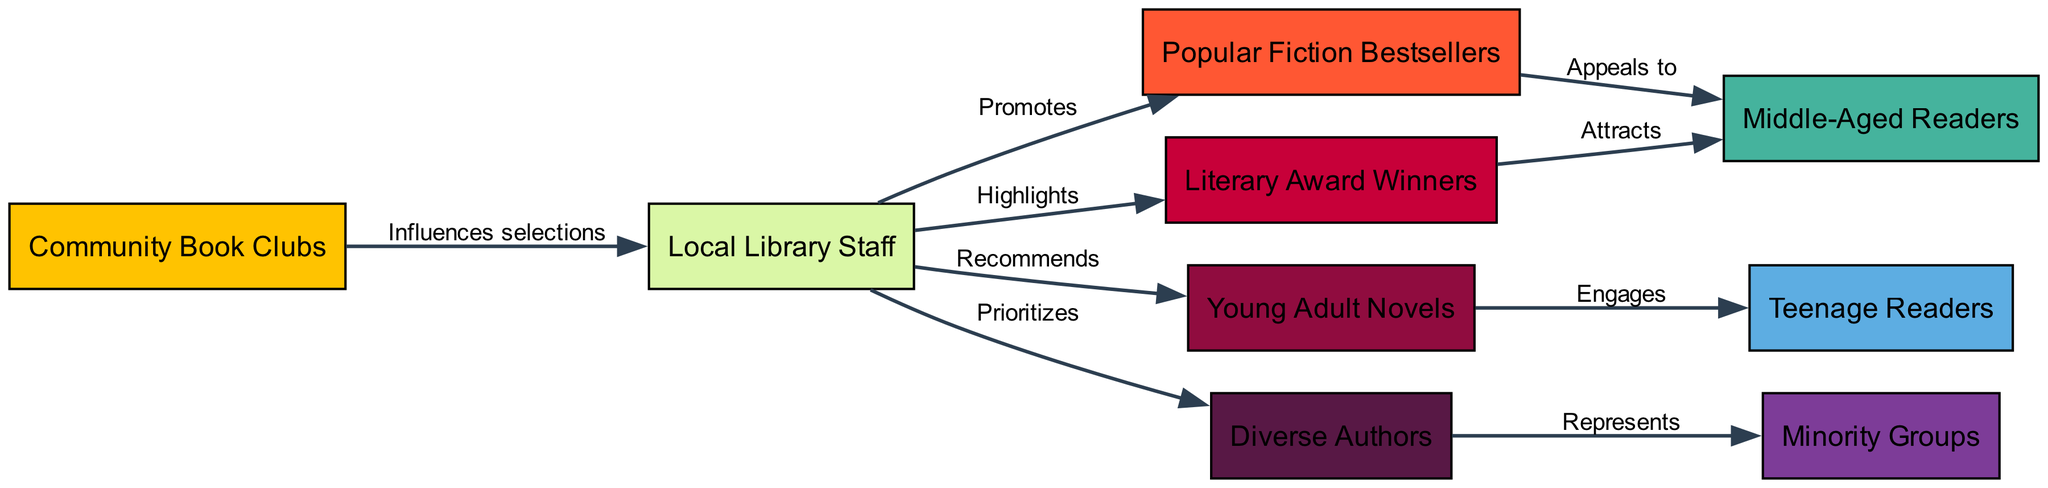What are the nodes in the diagram? The diagram consists of nodes that represent different elements of the book recommendation process. Specifically, the nodes are Community Book Clubs, Local Library Staff, Popular Fiction Bestsellers, Literary Award Winners, Young Adult Novels, Diverse Authors, Middle-Aged Readers, Teenage Readers, and Minority Groups.
Answer: Community Book Clubs, Local Library Staff, Popular Fiction Bestsellers, Literary Award Winners, Young Adult Novels, Diverse Authors, Middle-Aged Readers, Teenage Readers, Minority Groups How many edges are present in the diagram? The edges indicate the relationships between different nodes in the diagram. By counting the listed edges, we find there are a total of 9 edges connecting the various nodes.
Answer: 9 Which node is influenced by Community Book Clubs? In the diagram, Community Book Clubs have an edge directing to Local Library Staff, indicating they influence the selections made by this node.
Answer: Local Library Staff What do Local Library Staff promote? The diagram shows two relationships emanating from Local Library Staff: they promote Popular Fiction Bestsellers and highlight Literary Award Winners. Thus, both types of literature are promoted by this node.
Answer: Popular Fiction Bestsellers and Literary Award Winners Which demographic group is primarily engaged by Young Adult Novels? According to the diagram, Young Adult Novels have a direct relationship to Teenage Readers, signifying that this demographic group is primarily engaged by this type of literature.
Answer: Teenage Readers How do Diverse Authors connect to Minority Groups? The relationship in the diagram illustrates that Diverse Authors represent Minority Groups. This implies that literature by Diverse Authors plays a crucial role in representing the concerns and narratives of these groups.
Answer: Represents Which type of literature attracts Middle-Aged Readers? The diagram shows two pathways leading to Middle-Aged Readers: one from Popular Fiction Bestsellers and another from Literary Award Winners. This means both types of literature attract this demographic.
Answer: Popular Fiction Bestsellers and Literary Award Winners Who prioritizes Diverse Authors? The diagram indicates that Local Library Staff prioritize Diverse Authors in their recommendations, suggesting a conscious effort to promote literature from this group.
Answer: Local Library Staff How is the recommendation chain structured towards Minority Groups? The recommendation chain starts from Community Book Clubs influencing Local Library Staff, who in turn prioritize Diverse Authors. These authors subsequently represent Minority Groups, forming a chain that highlights the importance of diversity in book recommendations.
Answer: Community Book Clubs → Local Library Staff → Diverse Authors → Minority Groups 